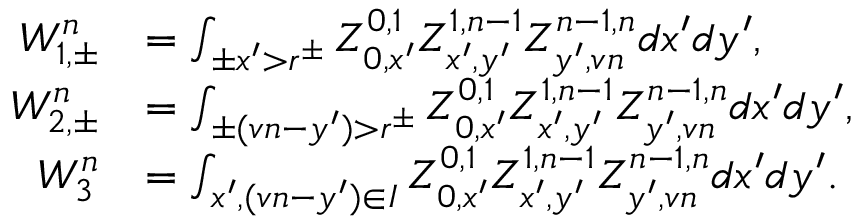<formula> <loc_0><loc_0><loc_500><loc_500>\begin{array} { r l } { W _ { 1 , \pm } ^ { n } } & { = \int _ { \pm x ^ { \prime } > r ^ { \pm } } Z _ { 0 , x ^ { \prime } } ^ { 0 , 1 } Z _ { x ^ { \prime } , y ^ { \prime } } ^ { 1 , n - 1 } Z _ { y ^ { \prime } , v n } ^ { n - 1 , n } d x ^ { \prime } d y ^ { \prime } , } \\ { W _ { 2 , \pm } ^ { n } } & { = \int _ { \pm ( v n - y ^ { \prime } ) > r ^ { \pm } } Z _ { 0 , x ^ { \prime } } ^ { 0 , 1 } Z _ { x ^ { \prime } , y ^ { \prime } } ^ { 1 , n - 1 } Z _ { y ^ { \prime } , v n } ^ { n - 1 , n } d x ^ { \prime } d y ^ { \prime } , } \\ { W _ { 3 } ^ { n } } & { = \int _ { x ^ { \prime } , ( v n - y ^ { \prime } ) \in I } Z _ { 0 , x ^ { \prime } } ^ { 0 , 1 } Z _ { x ^ { \prime } , y ^ { \prime } } ^ { 1 , n - 1 } Z _ { y ^ { \prime } , v n } ^ { n - 1 , n } d x ^ { \prime } d y ^ { \prime } . } \end{array}</formula> 